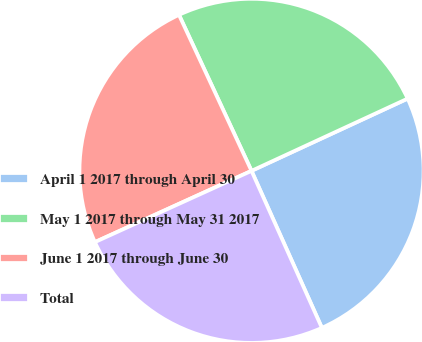<chart> <loc_0><loc_0><loc_500><loc_500><pie_chart><fcel>April 1 2017 through April 30<fcel>May 1 2017 through May 31 2017<fcel>June 1 2017 through June 30<fcel>Total<nl><fcel>25.19%<fcel>25.03%<fcel>24.87%<fcel>24.91%<nl></chart> 